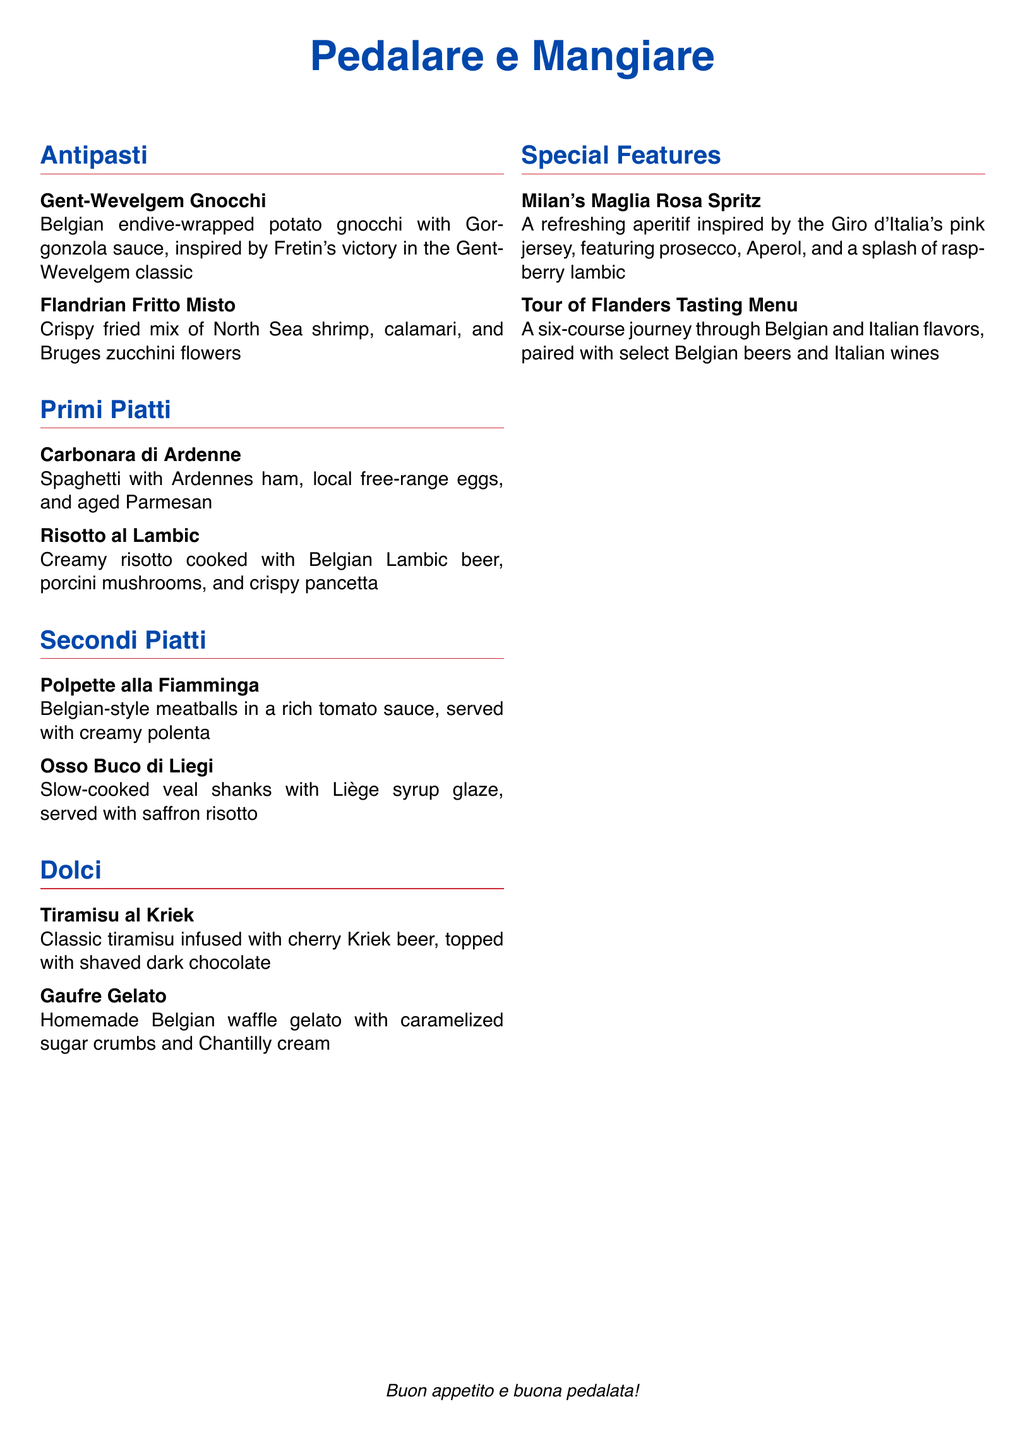What is the name of the restaurant? The restaurant name is prominently displayed at the top of the menu, which is "Pedalare e Mangiare."
Answer: Pedalare e Mangiare What is the first antipasto listed? The first antipasto listed is detailed in the Antipasti section of the menu, which is "Gent-Wevelgem Gnocchi."
Answer: Gent-Wevelgem Gnocchi What ingredient is featured in the Risotto al Lambic? The Risotto al Lambic includes Belgian Lambic beer as a key ingredient, listed in the Primi Piatti section.
Answer: Lambic beer How many courses are in the Tour of Flanders Tasting Menu? The description of the Tour of Flanders Tasting Menu specifies that it includes a six-course journey.
Answer: six What dessert features cherry beer? The dessert that incorporates cherry beer is stated in the Dolci section, which is "Tiramisu al Kriek."
Answer: Tiramisu al Kriek Which dish is inspired by Fretin's victory in a cycling classic? The dish inspired by Fretin's victory is mentioned in the Antipasti section as "Gent-Wevelgem Gnocchi."
Answer: Gent-Wevelgem Gnocchi What type of meat is used in Polpette alla Fiamminga? The menu lists that Polpette alla Fiamminga uses, specifically Belgian-style meatballs, which are derived from beef.
Answer: beef What color is assigned to Italian-themed text in the menu? The color used for Italian-themed text is clearly stated in the document as "italianred."
Answer: italianred 